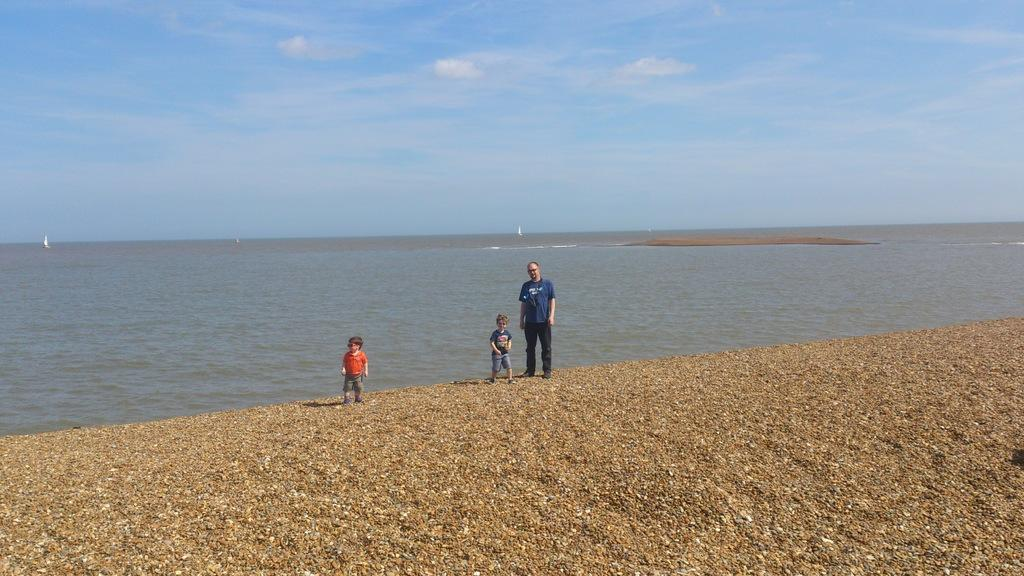Who is the main subject in the center of the image? There is a man in the center of the image. Who are the other people with the man? There are two kids standing with the man. What can be seen in the background of the image? The sky, clouds, boats, and water are visible in the background of the image. What grade is the vase in the image? There is no vase present in the image. What type of war is depicted in the image? There is no war depicted in the image; it features a man and two kids in the foreground with a background of sky, clouds, boats, and water. 